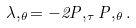<formula> <loc_0><loc_0><loc_500><loc_500>\lambda , _ { \theta } = - 2 P , _ { \tau } P , _ { \theta } .</formula> 